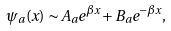<formula> <loc_0><loc_0><loc_500><loc_500>\psi _ { a } ( x ) \sim A _ { a } e ^ { \beta x } + B _ { a } e ^ { - \beta x } ,</formula> 